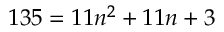<formula> <loc_0><loc_0><loc_500><loc_500>1 3 5 = 1 1 n ^ { 2 } + 1 1 n + 3</formula> 